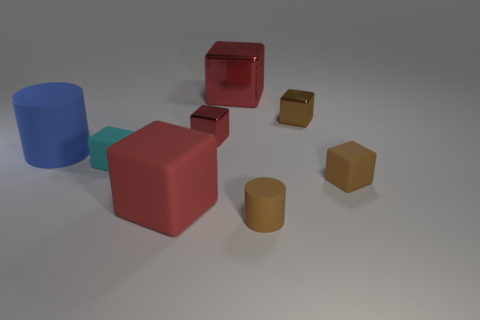Subtract all purple cylinders. How many red cubes are left? 3 Subtract 1 blocks. How many blocks are left? 5 Subtract all cyan cubes. How many cubes are left? 5 Subtract all small cyan matte cubes. How many cubes are left? 5 Subtract all purple blocks. Subtract all yellow cylinders. How many blocks are left? 6 Add 1 large red objects. How many objects exist? 9 Subtract all cylinders. How many objects are left? 6 Add 5 small brown blocks. How many small brown blocks exist? 7 Subtract 0 cyan cylinders. How many objects are left? 8 Subtract all small brown rubber things. Subtract all big blue objects. How many objects are left? 5 